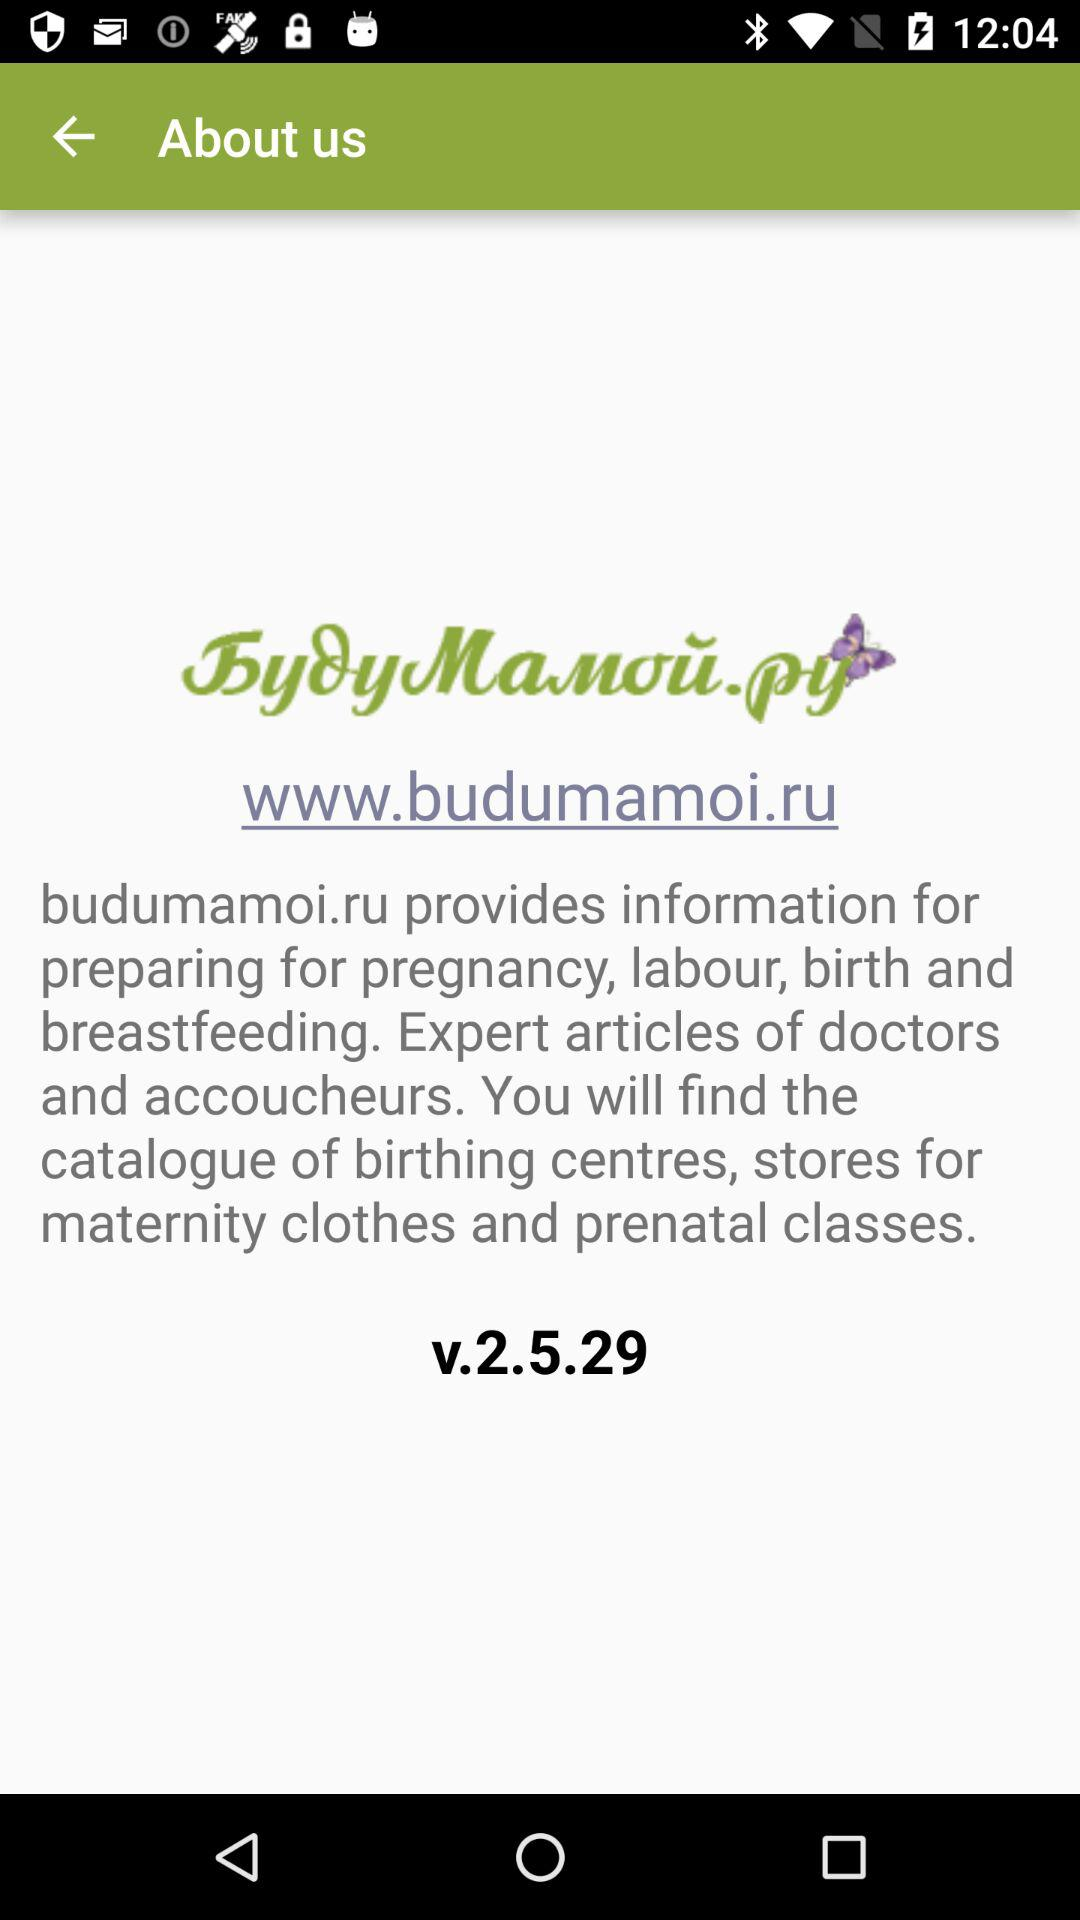What type of information budumamoi.ru provide us? - What type of information does "budumamoi.ru" provide us? "budumamoi.ru" provides information for preparing for pregnancy, labour, birth and breastfeeding. 